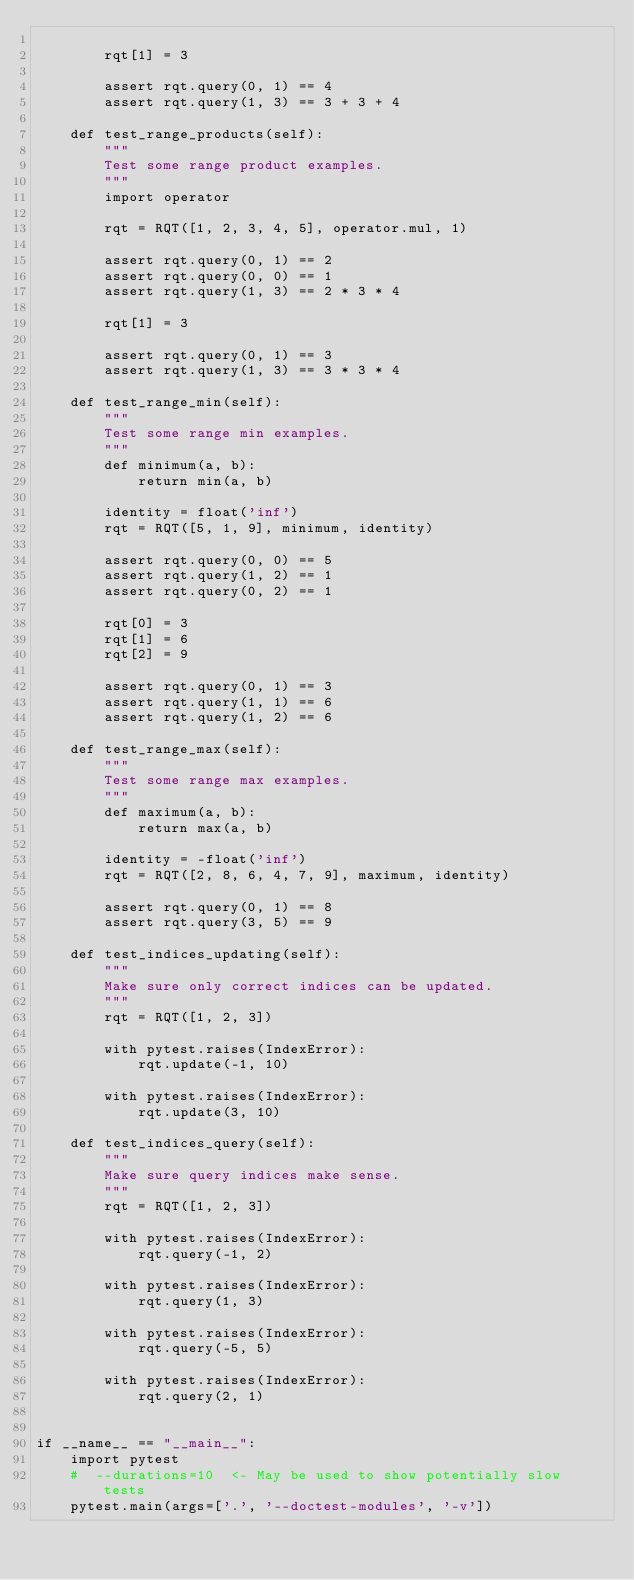Convert code to text. <code><loc_0><loc_0><loc_500><loc_500><_Python_>
        rqt[1] = 3

        assert rqt.query(0, 1) == 4
        assert rqt.query(1, 3) == 3 + 3 + 4
        
    def test_range_products(self):
        """
        Test some range product examples.
        """
        import operator
        
        rqt = RQT([1, 2, 3, 4, 5], operator.mul, 1)
        
        assert rqt.query(0, 1) == 2
        assert rqt.query(0, 0) == 1
        assert rqt.query(1, 3) == 2 * 3 * 4

        rqt[1] = 3

        assert rqt.query(0, 1) == 3
        assert rqt.query(1, 3) == 3 * 3 * 4
        
    def test_range_min(self):
        """
        Test some range min examples.
        """
        def minimum(a, b):
            return min(a, b)

        identity = float('inf')
        rqt = RQT([5, 1, 9], minimum, identity)
        
        assert rqt.query(0, 0) == 5
        assert rqt.query(1, 2) == 1
        assert rqt.query(0, 2) == 1

        rqt[0] = 3
        rqt[1] = 6
        rqt[2] = 9

        assert rqt.query(0, 1) == 3
        assert rqt.query(1, 1) == 6
        assert rqt.query(1, 2) == 6
        
    def test_range_max(self):
        """
        Test some range max examples.
        """
        def maximum(a, b):
            return max(a, b)
        
        identity = -float('inf')
        rqt = RQT([2, 8, 6, 4, 7, 9], maximum, identity)
        
        assert rqt.query(0, 1) == 8
        assert rqt.query(3, 5) == 9
        
    def test_indices_updating(self):
        """
        Make sure only correct indices can be updated.
        """
        rqt = RQT([1, 2, 3])
        
        with pytest.raises(IndexError):
            rqt.update(-1, 10)
            
        with pytest.raises(IndexError):
            rqt.update(3, 10)
            
    def test_indices_query(self):
        """
        Make sure query indices make sense.
        """
        rqt = RQT([1, 2, 3])
        
        with pytest.raises(IndexError):
            rqt.query(-1, 2)
            
        with pytest.raises(IndexError):
            rqt.query(1, 3)
            
        with pytest.raises(IndexError):
            rqt.query(-5, 5)
            
        with pytest.raises(IndexError):
            rqt.query(2, 1)


if __name__ == "__main__":
    import pytest
    #  --durations=10  <- May be used to show potentially slow tests
    pytest.main(args=['.', '--doctest-modules', '-v'])</code> 